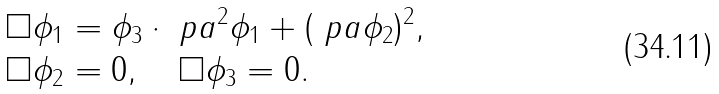Convert formula to latex. <formula><loc_0><loc_0><loc_500><loc_500>\square \phi _ { 1 } & = \phi _ { 3 } \cdot \ p a ^ { 2 } \phi _ { 1 } + ( \ p a \phi _ { 2 } ) ^ { 2 } , \\ \Box \phi _ { 2 } & = 0 , \quad \Box \phi _ { 3 } = 0 .</formula> 